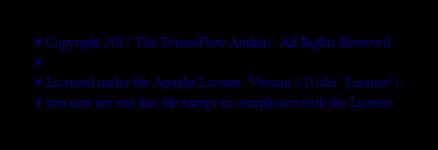Convert code to text. <code><loc_0><loc_0><loc_500><loc_500><_Python_># Copyright 2017 The TensorFlow Authors. All Rights Reserved.
#
# Licensed under the Apache License, Version 2.0 (the "License");
# you may not use this file except in compliance with the License.</code> 